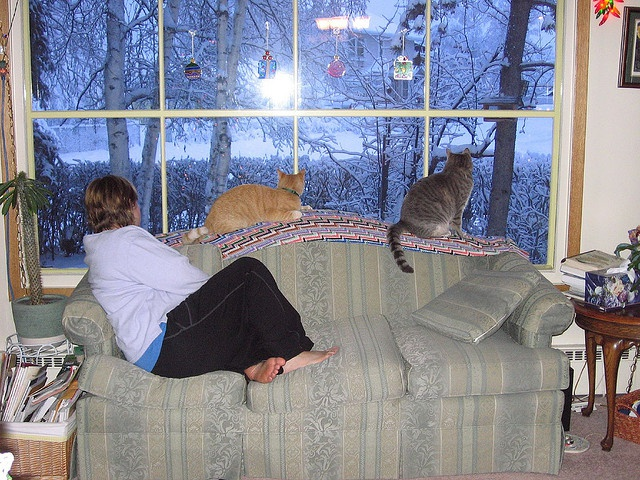Describe the objects in this image and their specific colors. I can see couch in olive, darkgray, and gray tones, people in olive, black, lavender, and darkgray tones, potted plant in olive, gray, black, darkgreen, and darkgray tones, cat in olive, gray, black, and darkgray tones, and cat in olive, gray, tan, and darkgray tones in this image. 